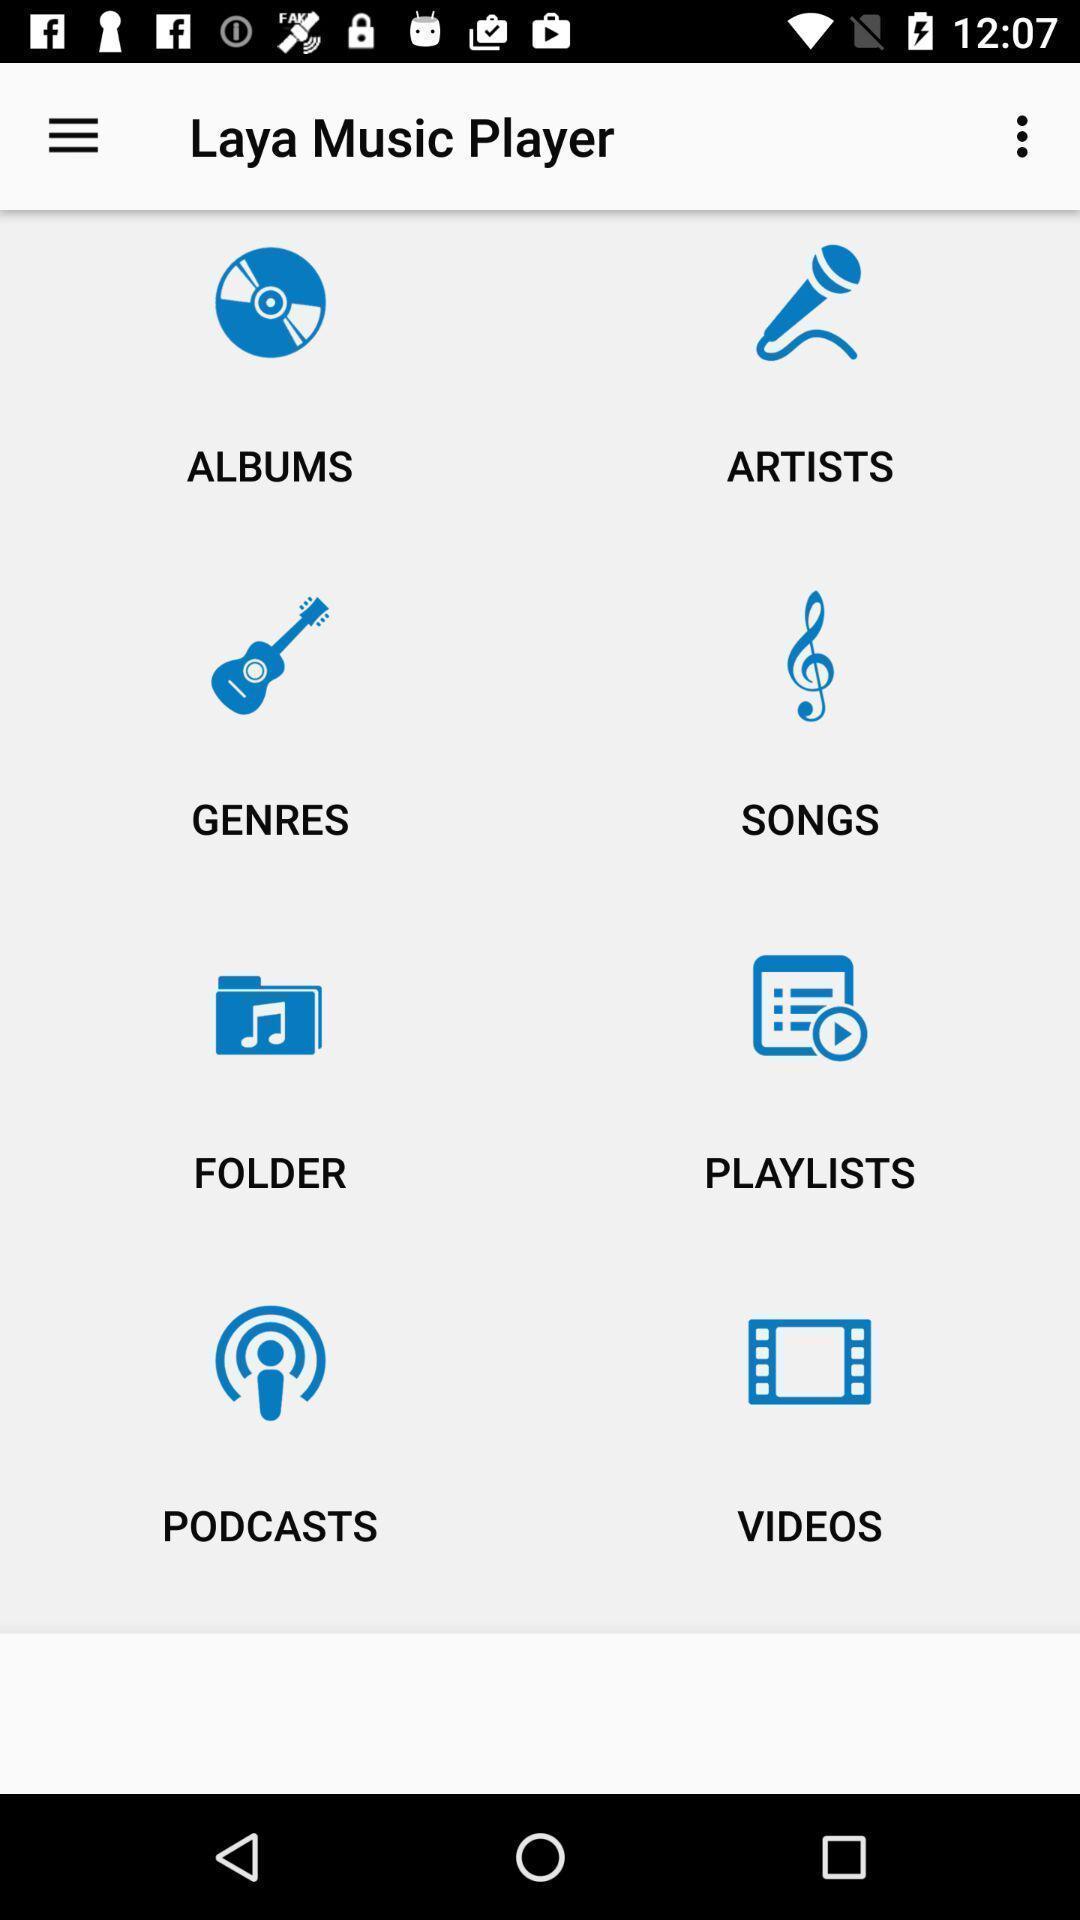Provide a detailed account of this screenshot. Screen displaying the various features in a music player app. 